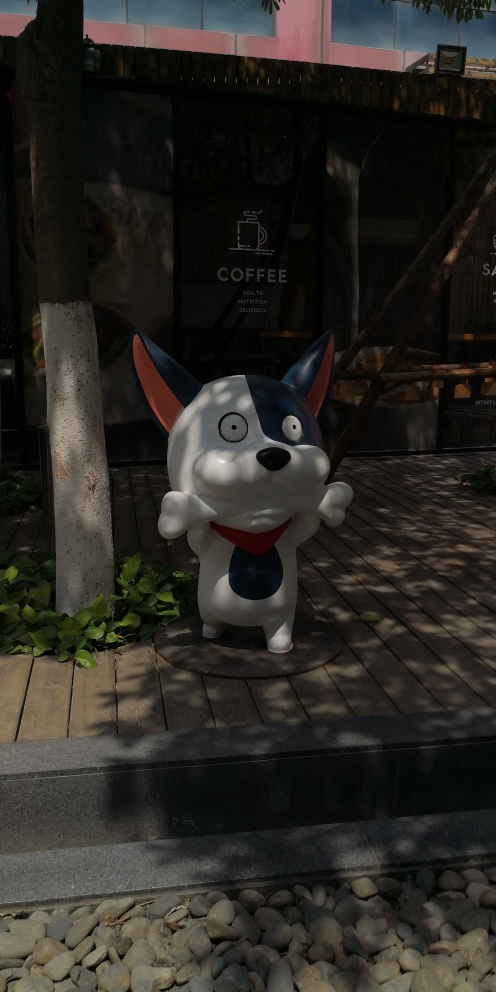Discuss and assess the quality of the picture, and form conclusions based on your evaluation. The image predominantly features a cartoonish, likely promotional, figure akin to a dog, positioned in front of a coffee shop. The figure is well-captured in terms of focus and color contrast against the dimmer background. However, the image struggles with a few key aspects: The lighting lacks balance, casting shadows on the shop and overexposing parts of the character's face. Additional details, such as the shop’s façade and surrounding architecture, are underrepresented due to this lighting imbalance. The composition, while centralizing the character, seems slightly tilted, which gives a casual, less professional feel to the photograph. Overall, this image serves well for casual or promotional use but might require adjustments for professional quality presentations. 